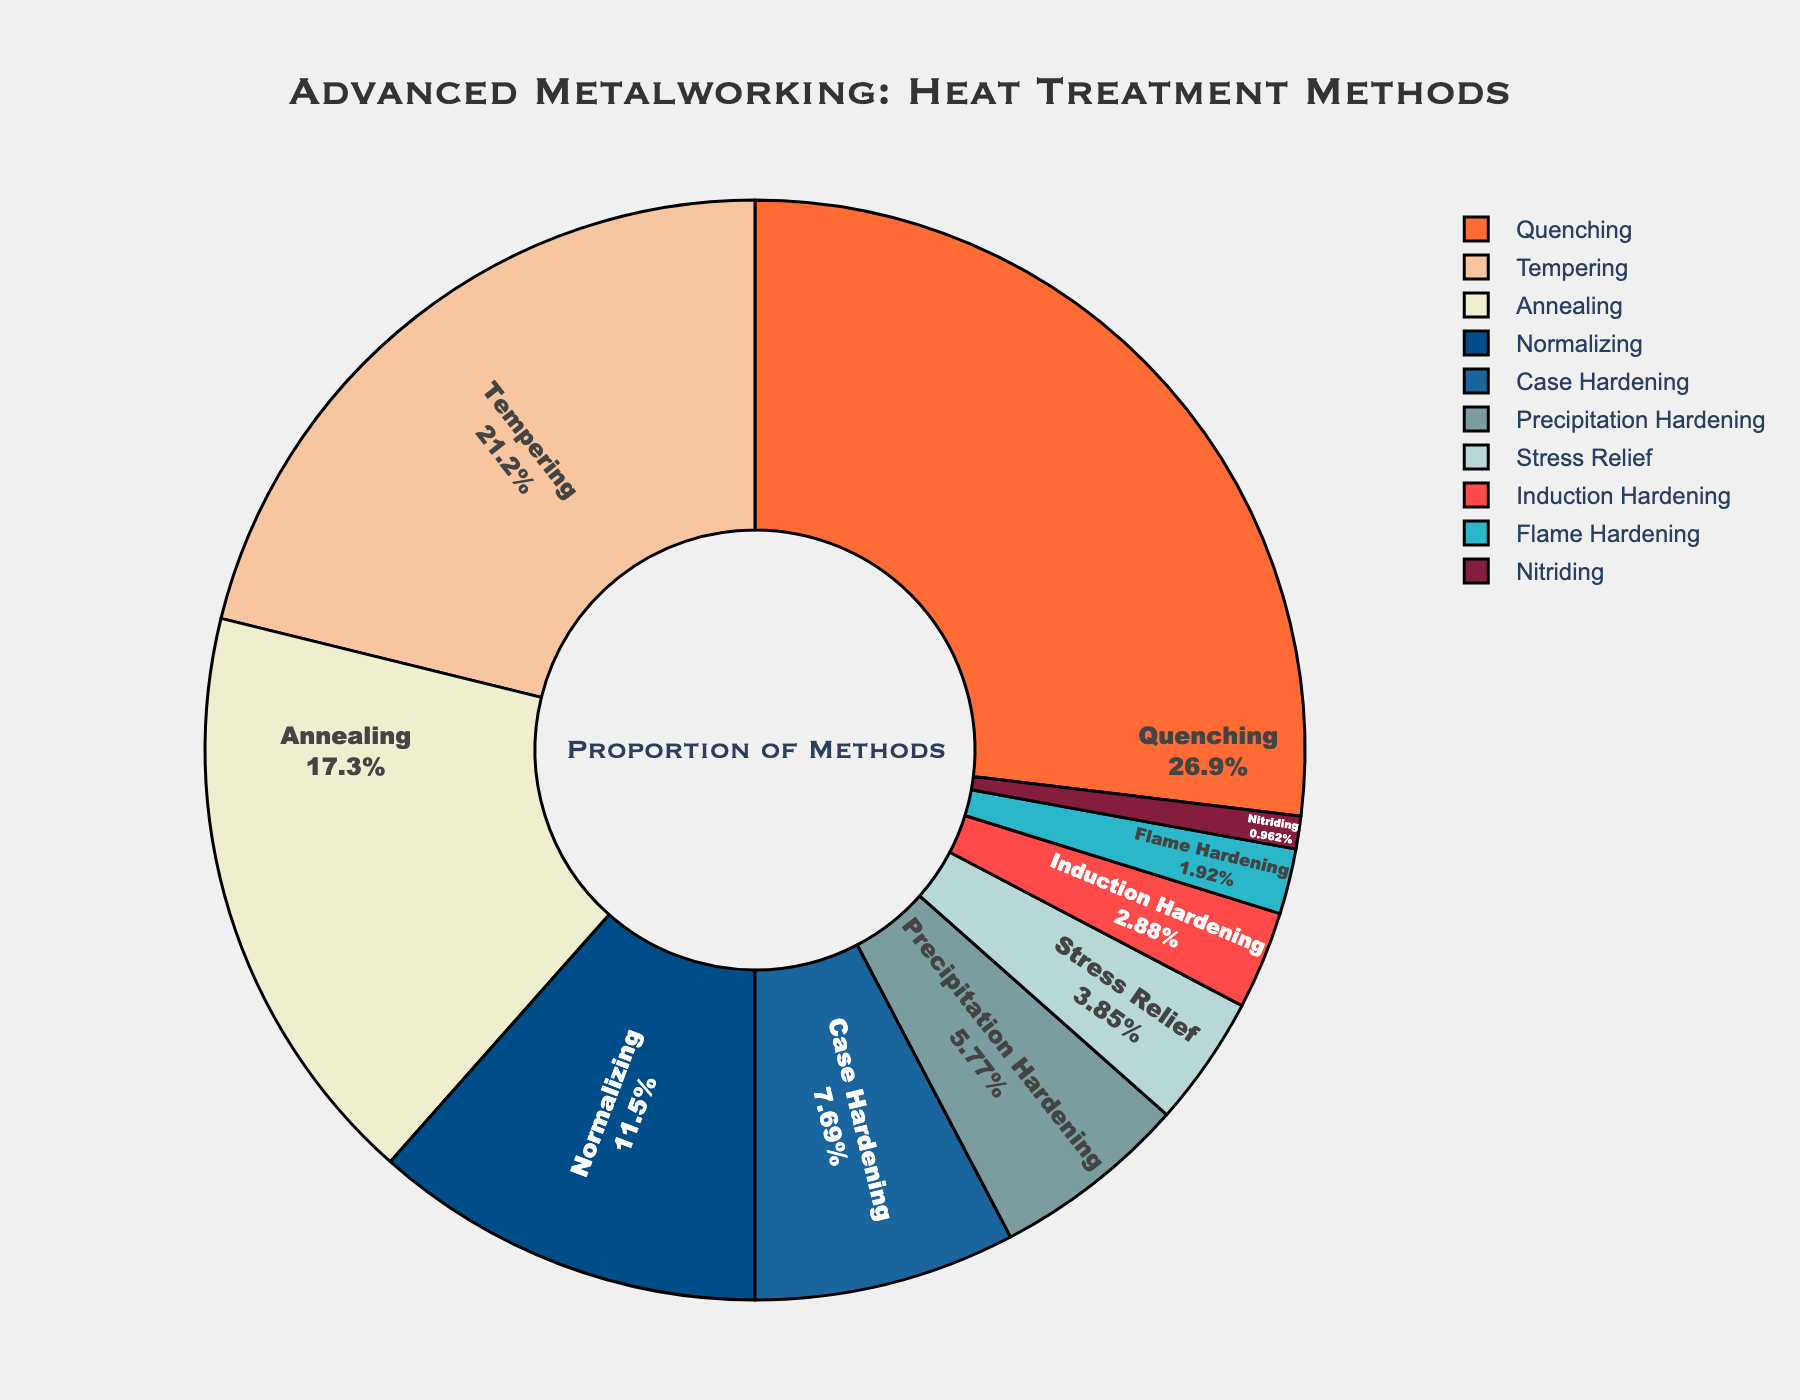What heat treatment method is employed the most? The largest segment in the pie chart represents the method with the highest percentage. The "Quenching" segment appears to be the largest.
Answer: Quenching What is the combined percentage of Tempering and Annealing? Add the percentages of Tempering and Annealing segments. Tempering is 22%, and Annealing is 18%. So, the combined percentage is 22 + 18 = 40%.
Answer: 40% Which heat treatment method has the smallest proportion? The smallest segment in the pie chart indicates the method with the least percentage. The "Nitriding" segment is the smallest.
Answer: Nitriding How does the proportion of Case Hardening compare to Precipitation Hardening? Compare the percentages of Case Hardening (8%) and Precipitation Hardening (6%). Case Hardening has a higher percentage than Precipitation Hardening.
Answer: Case Hardening is greater What is the percentage difference between Quenching and Normalizing? Subtract the percentage of Normalizing (12%) from Quenching (28%) to find the difference: 28 - 12 = 16%.
Answer: 16% What is the total percentage of the bottom three methods by proportion? Add the percentages of Induction Hardening (3%), Flame Hardening (2%), and Nitriding (1%). The total is 3 + 2 + 1 = 6%.
Answer: 6% What color represents Stress Relief in the pie chart? Identify the segment labeled "Stress Relief" and note its color. Stress Relief is represented by the color closest to '#B8D8D8', a shade of blue-green.
Answer: Blue-green Is the combined proportion of Case Hardening and Tempering greater than Quenching? Add the percentages of Case Hardening (8%) and Tempering (22%) and compare to Quenching (28%). 8 + 22 = 30%, which is greater than 28%.
Answer: Yes How many heat treatment methods have a proportion equal to or above 10%? Count the segments with percentages equal to or above 10%: Quenching (28%), Tempering (22%), Annealing (18%), and Normalizing (12%). Total is 4 methods.
Answer: 4 What is the average percentage of Quenching, Tempering, and Annealing? Add the percentages of Quenching (28%), Tempering (22%), and Annealing (18%) and divide by 3: (28 + 22 + 18) / 3 = 22.7%.
Answer: 22.7% 